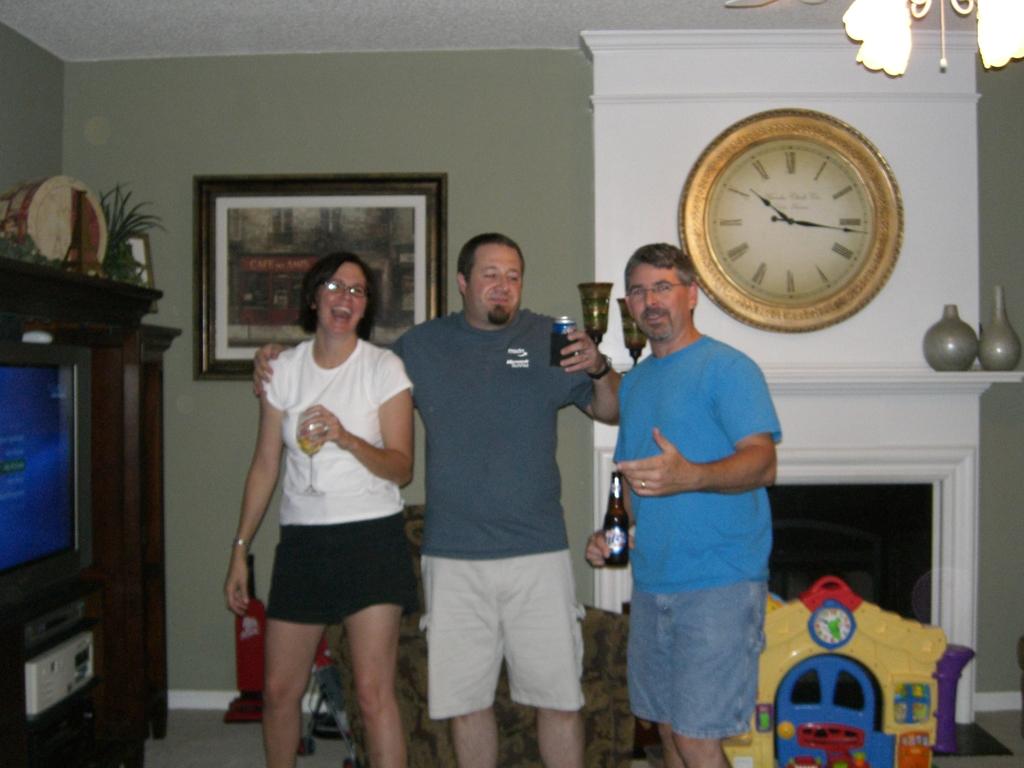The time on the clock reads?
Keep it short and to the point. 10:16. 